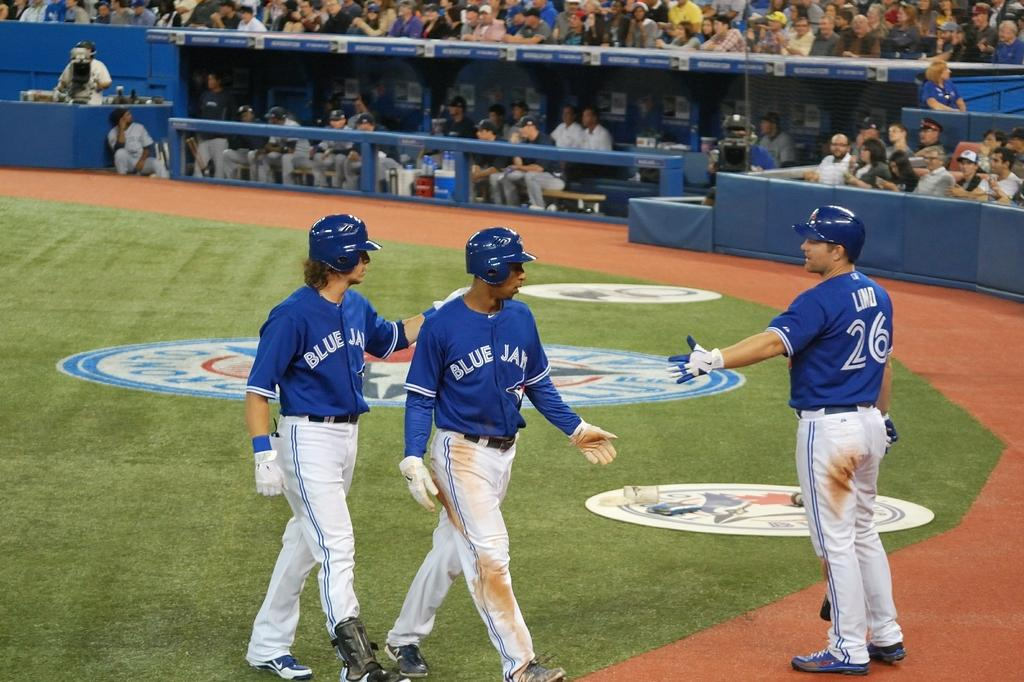<image>
Summarize the visual content of the image. baseball players in Blue Jays jerseys walk off the field 